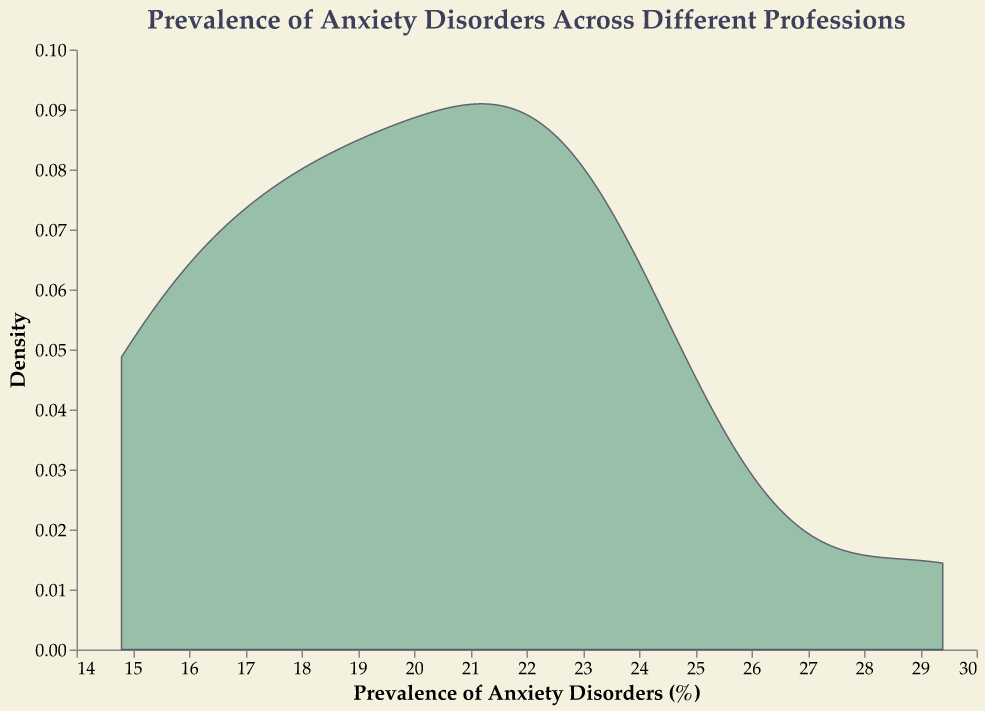What is the title of the figure? The title of the figure is typically located at the top of the plot and gives a summary of what the chart represents. Here, the title is "Prevalence of Anxiety Disorders Across Different Professions."
Answer: Prevalence of Anxiety Disorders Across Different Professions What does the x-axis represent? The x-axis is labeled with "Prevalence of Anxiety Disorders (%)" which indicates it shows the percentage prevalence of anxiety disorders across different professions.
Answer: Prevalence of Anxiety Disorders (%) Which profession has the highest prevalence of anxiety disorders? By examining the data values, we can identify the highest percentage. The "Lawyers" profession has the highest prevalence with 29.4%.
Answer: Lawyers What is the approximate prevalence range with the highest density? In density plots, the region with the highest density peaks indicates where most of the data points are concentrated. In this plot, the highest density peak appears around the 20-22% range.
Answer: 20-22% How many professions have a prevalence percentage greater than 20%? To answer this, we count the number of professions with prevalence percentages above 20%. Those are Nurses (23.4%), Social Workers (22.8%), Software Developers (22.0%), Journalists (20.5%), Artists (24.7%), Financial Analysts (21.3%), and Product Managers (22.5%), making it 7 professions.
Answer: 7 Which profession has a prevalence percentage closest to the mean prevalence of all professions? To find this, first, calculate the mean prevalence percentage. Summing all percentages: 15.2 + 19.1 + 23.4 + 22.8 + 17.3 + 18.9 + 22.0 + 29.4 + 16.2 + 14.8 + 20.5 + 24.7 + 18.4 + 21.3 + 22.5 = 306.5. The mean is 306.5 / 15 = 20.43%. The closest profession to this mean is Journalists, with 20.5%.
Answer: Journalists What is the difference in prevalence percentage between the profession with the highest and the lowest values? The profession with the highest prevalence is Lawyers (29.4%), and the lowest is Construction Workers (14.8%). The difference is 29.4 - 14.8 = 14.6%.
Answer: 14.6% Around which prevalence percentage is the density plot most spread? The spread of the plot indicates the range where most data points lie. The density plot spreads most widely around the 15-25% range, indicating a broad variation in this range.
Answer: 15-25% Is there a profession whose prevalence percentage is an outlier on the higher end? An outlier would be significantly different from the rest. Lawyers, with a prevalence percentage of 29.4%, appear to be noticeably higher compared to others and thus can be considered an outlier.
Answer: Lawyers What can be inferred about the distribution shape of anxiety prevalence in different professions from the density plot? The density plot appears to have a unimodal distribution with a peak around 20-22% and a right skew, indicating that most professions have prevalence percentages around this range and fewer professions have a much higher prevalence.
Answer: Unimodal with a right skew 